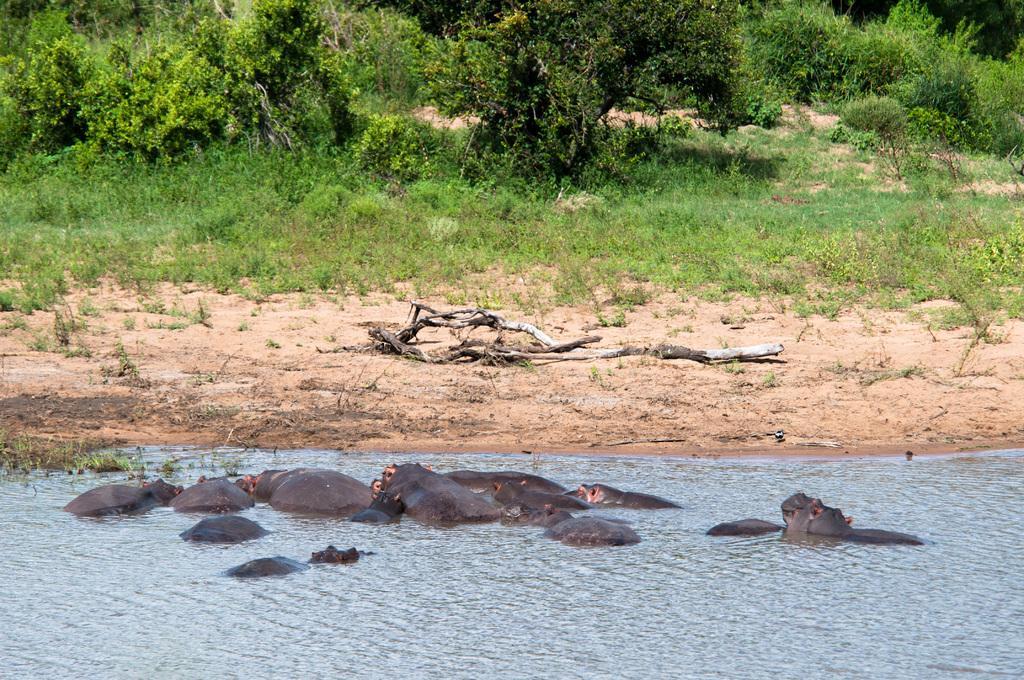Can you describe this image briefly? In the picture I can see animals in the water. In the background I can see the grass, plants and wooden objects on the ground. 